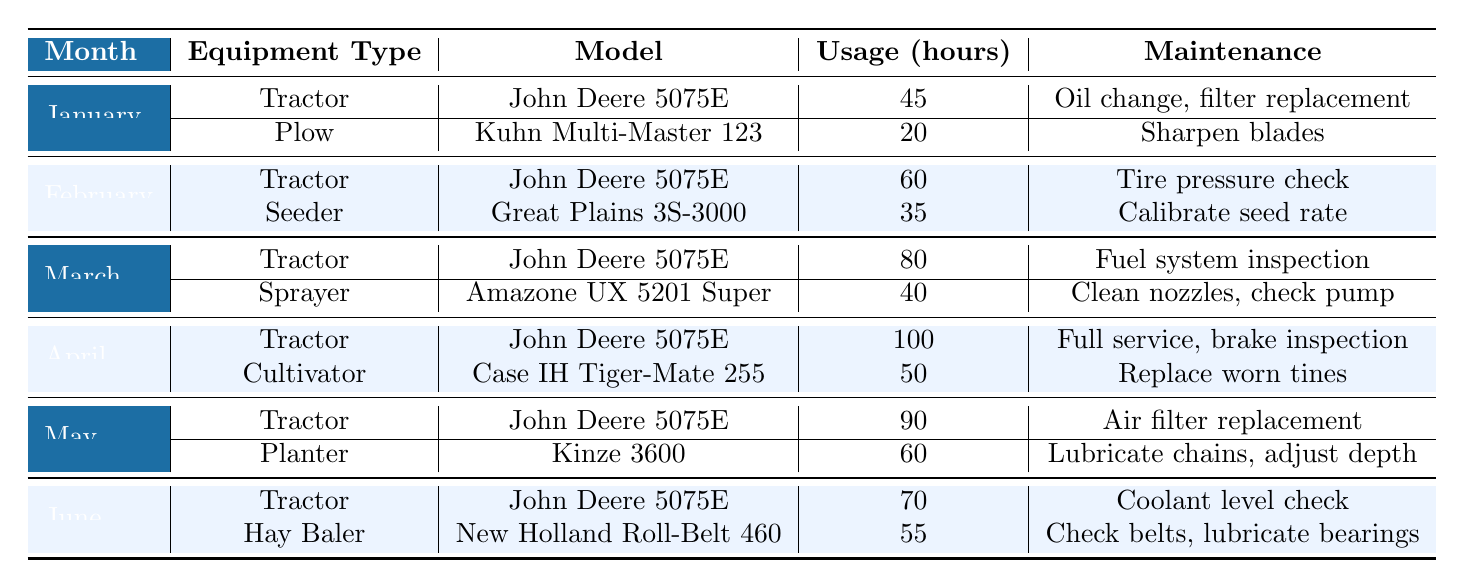What was the maintenance task for the Hay Baler in June? In the table, under the month of June, the Hay Baler (New Holland Roll-Belt 460) has a maintenance task listed as "Check belts, lubricate bearings."
Answer: Check belts, lubricate bearings How many hours did the John Deere 5075E tractor get used in total from January to June? To find the total usage hours of the John Deere 5075E from January to June, we sum the monthly usage: 45 (January) + 60 (February) + 80 (March) + 100 (April) + 90 (May) + 70 (June) = 445 hours.
Answer: 445 hours Did the Seeder have any maintenance tasks listed? Looking at the table, the Seeder (Great Plains 3S-3000) is listed in February with a maintenance task of "Calibrate seed rate." Therefore, the Seeder did have maintenance tasks.
Answer: Yes Which month had the highest usage for the Tractor? By reviewing the table, the month of April has the highest usage for the Tractor (John Deere 5075E) at 100 hours compared to other months.
Answer: April What is the average usage of the Tractor across all months? The usage hours are as follows: 45 (January), 60 (February), 80 (March), 100 (April), 90 (May), and 70 (June). Adding these gives 445 hours. Dividing by 6 months, the average usage is 445/6 = 74.17 hours.
Answer: 74.17 hours Was any maintenance scheduled for the Plow in March? The table does not list any maintenance tasks for the Plow in March because the Plow is only mentioned in January. Therefore, no maintenance was scheduled for the Plow in March.
Answer: No In which month did the Cultivator receive maintenance and what was it? The Cultivator (Case IH Tiger-Mate 255) received maintenance in April, and the maintenance task was to "Replace worn tines."
Answer: April, Replace worn tines What are the total usage hours for all equipment types in May? The equipment usage in May includes the Tractor (90 hours) and the Planter (60 hours). Therefore, the total usage in May is 90 + 60 = 150 hours.
Answer: 150 hours Which piece of equipment had a maintenance task involving checking coolant levels? The table states that the maintenance task involving checking coolant levels was for the Tractor (John Deere 5075E) in June.
Answer: Tractor (John Deere 5075E) Was the Sprayer used more in March than the Plow was used in January? The Sprayer (Amazone UX 5201 Super) was used for 40 hours in March, while the Plow (Kuhn Multi-Master 123) was used for 20 hours in January. Since 40 is greater than 20, the Sprayer was used more.
Answer: Yes 